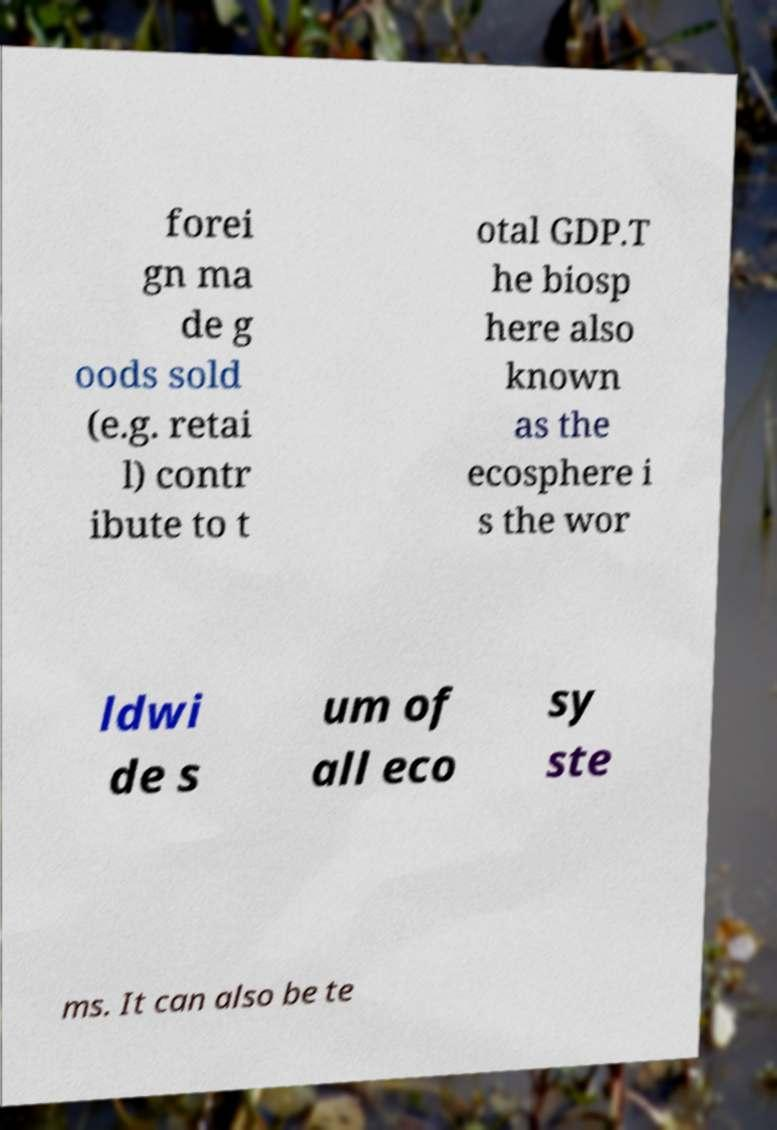Please identify and transcribe the text found in this image. forei gn ma de g oods sold (e.g. retai l) contr ibute to t otal GDP.T he biosp here also known as the ecosphere i s the wor ldwi de s um of all eco sy ste ms. It can also be te 